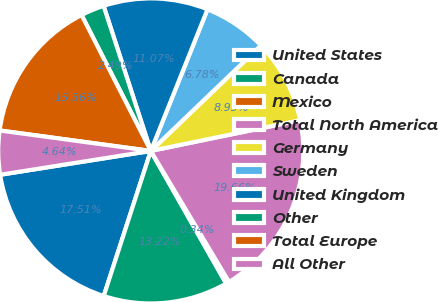Convert chart to OTSL. <chart><loc_0><loc_0><loc_500><loc_500><pie_chart><fcel>United States<fcel>Canada<fcel>Mexico<fcel>Total North America<fcel>Germany<fcel>Sweden<fcel>United Kingdom<fcel>Other<fcel>Total Europe<fcel>All Other<nl><fcel>17.51%<fcel>13.22%<fcel>0.34%<fcel>19.66%<fcel>8.93%<fcel>6.78%<fcel>11.07%<fcel>2.49%<fcel>15.36%<fcel>4.64%<nl></chart> 